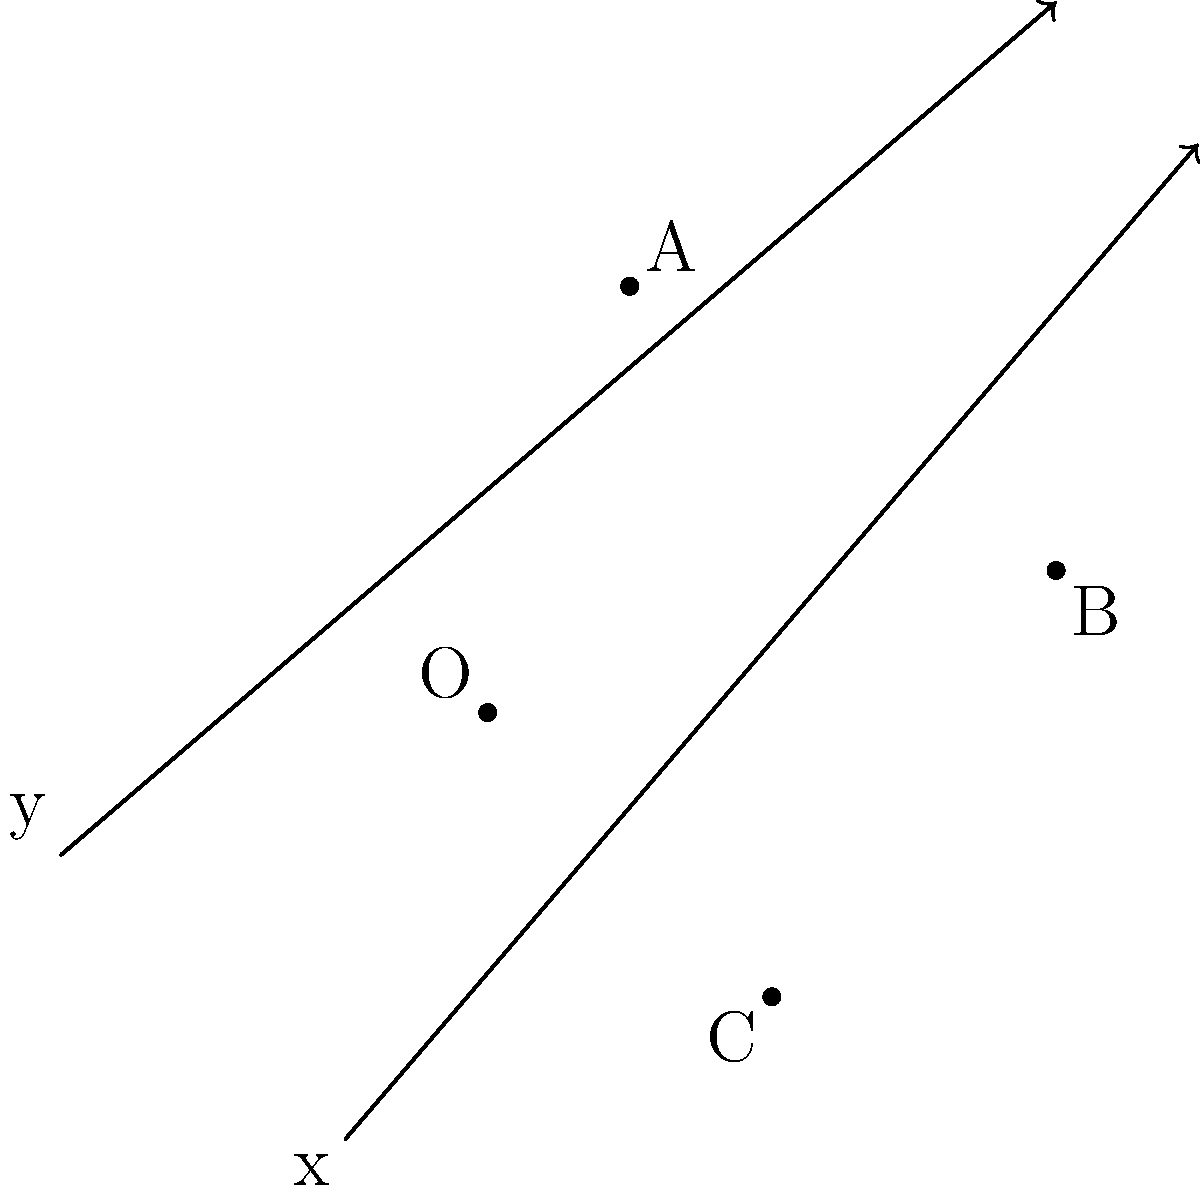In a soccer field represented by a coordinate plane, three players A, B, and C are positioned at (1,3), (4,1), and (2,-2) respectively. Calculate the area of the triangle formed by these three players' positions. To find the area of the triangle formed by the three players' positions, we can use the formula for the area of a triangle given the coordinates of its vertices:

Area = $\frac{1}{2}|x_1(y_2 - y_3) + x_2(y_3 - y_1) + x_3(y_1 - y_2)|$

Where $(x_1,y_1)$, $(x_2,y_2)$, and $(x_3,y_3)$ are the coordinates of the three vertices.

Step 1: Identify the coordinates
A: $(x_1,y_1) = (1,3)$
B: $(x_2,y_2) = (4,1)$
C: $(x_3,y_3) = (2,-2)$

Step 2: Substitute the values into the formula
Area = $\frac{1}{2}|1(1 - (-2)) + 4((-2) - 3) + 2(3 - 1)|$

Step 3: Simplify the expressions inside the parentheses
Area = $\frac{1}{2}|1(3) + 4(-5) + 2(2)|$

Step 4: Multiply
Area = $\frac{1}{2}|3 - 20 + 4|$

Step 5: Add the numbers inside the absolute value bars
Area = $\frac{1}{2}|-13|$

Step 6: Calculate the absolute value
Area = $\frac{1}{2}(13)$

Step 7: Divide
Area = $6.5$ square units

Therefore, the area of the triangle formed by the three players' positions is 6.5 square units.
Answer: 6.5 square units 